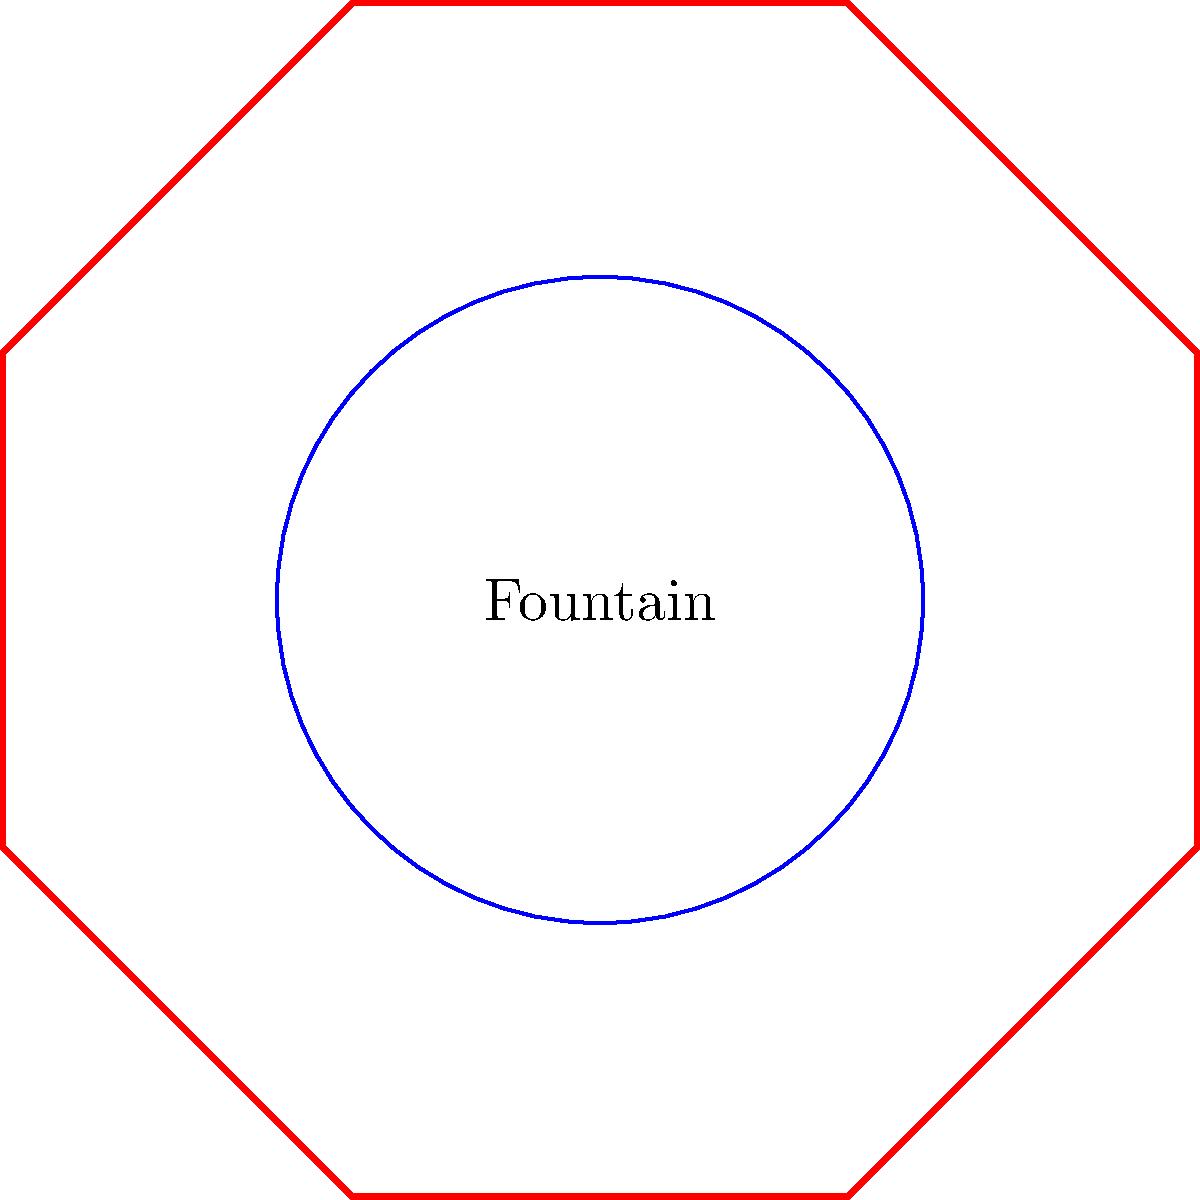The historic Forsyth Park fountain in Savannah is surrounded by an octagonal wrought iron fence. If the fountain has a diameter of 10 feet and the fence is placed 5 feet away from the edge of the fountain on all sides, estimate the area enclosed by the fence, rounded to the nearest square foot. Let's approach this step-by-step:

1) First, we need to find the radius of the circular area that includes both the fountain and the 5-foot buffer zone:
   Radius = (Fountain diameter / 2) + Buffer
   $R = (10 / 2) + 5 = 5 + 5 = 10$ feet

2) Now, we have an octagon with an inscribed circle of radius 10 feet. To find the area of this octagon, we can use the formula:

   $A = 2R^2(1 + \sqrt{2})$

   Where $R$ is the radius of the inscribed circle.

3) Let's plug in our value:
   $A = 2(10^2)(1 + \sqrt{2})$
   $A = 200(1 + \sqrt{2})$
   $A = 200 + 200\sqrt{2}$

4) Calculate $200\sqrt{2}$:
   $200\sqrt{2} \approx 282.84$

5) Add this to 200:
   $200 + 282.84 = 482.84$ square feet

6) Rounding to the nearest square foot:
   483 square feet
Answer: 483 sq ft 